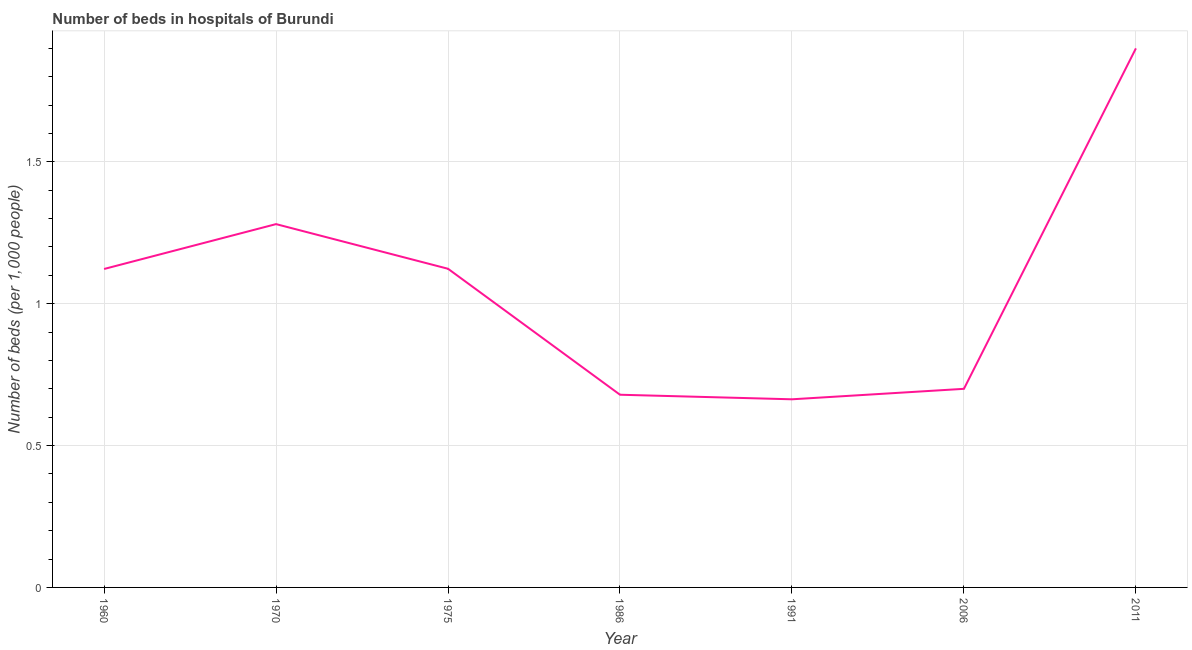Across all years, what is the minimum number of hospital beds?
Keep it short and to the point. 0.66. In which year was the number of hospital beds maximum?
Keep it short and to the point. 2011. What is the sum of the number of hospital beds?
Your answer should be compact. 7.47. What is the difference between the number of hospital beds in 1975 and 2006?
Your response must be concise. 0.42. What is the average number of hospital beds per year?
Keep it short and to the point. 1.07. What is the median number of hospital beds?
Ensure brevity in your answer.  1.12. In how many years, is the number of hospital beds greater than 0.5 %?
Provide a succinct answer. 7. What is the ratio of the number of hospital beds in 1970 to that in 2006?
Provide a succinct answer. 1.83. Is the number of hospital beds in 1991 less than that in 2011?
Your answer should be very brief. Yes. Is the difference between the number of hospital beds in 1960 and 1970 greater than the difference between any two years?
Your answer should be compact. No. What is the difference between the highest and the second highest number of hospital beds?
Give a very brief answer. 0.62. What is the difference between the highest and the lowest number of hospital beds?
Your answer should be compact. 1.24. In how many years, is the number of hospital beds greater than the average number of hospital beds taken over all years?
Offer a terse response. 4. How many lines are there?
Provide a short and direct response. 1. What is the difference between two consecutive major ticks on the Y-axis?
Give a very brief answer. 0.5. Does the graph contain any zero values?
Provide a succinct answer. No. Does the graph contain grids?
Give a very brief answer. Yes. What is the title of the graph?
Give a very brief answer. Number of beds in hospitals of Burundi. What is the label or title of the Y-axis?
Ensure brevity in your answer.  Number of beds (per 1,0 people). What is the Number of beds (per 1,000 people) of 1960?
Offer a very short reply. 1.12. What is the Number of beds (per 1,000 people) of 1970?
Your answer should be compact. 1.28. What is the Number of beds (per 1,000 people) in 1975?
Your answer should be very brief. 1.12. What is the Number of beds (per 1,000 people) in 1986?
Make the answer very short. 0.68. What is the Number of beds (per 1,000 people) in 1991?
Offer a very short reply. 0.66. What is the Number of beds (per 1,000 people) in 2011?
Your answer should be very brief. 1.9. What is the difference between the Number of beds (per 1,000 people) in 1960 and 1970?
Provide a succinct answer. -0.16. What is the difference between the Number of beds (per 1,000 people) in 1960 and 1975?
Give a very brief answer. -0. What is the difference between the Number of beds (per 1,000 people) in 1960 and 1986?
Give a very brief answer. 0.44. What is the difference between the Number of beds (per 1,000 people) in 1960 and 1991?
Ensure brevity in your answer.  0.46. What is the difference between the Number of beds (per 1,000 people) in 1960 and 2006?
Offer a very short reply. 0.42. What is the difference between the Number of beds (per 1,000 people) in 1960 and 2011?
Make the answer very short. -0.78. What is the difference between the Number of beds (per 1,000 people) in 1970 and 1975?
Provide a succinct answer. 0.16. What is the difference between the Number of beds (per 1,000 people) in 1970 and 1986?
Ensure brevity in your answer.  0.6. What is the difference between the Number of beds (per 1,000 people) in 1970 and 1991?
Offer a terse response. 0.62. What is the difference between the Number of beds (per 1,000 people) in 1970 and 2006?
Offer a very short reply. 0.58. What is the difference between the Number of beds (per 1,000 people) in 1970 and 2011?
Ensure brevity in your answer.  -0.62. What is the difference between the Number of beds (per 1,000 people) in 1975 and 1986?
Make the answer very short. 0.44. What is the difference between the Number of beds (per 1,000 people) in 1975 and 1991?
Give a very brief answer. 0.46. What is the difference between the Number of beds (per 1,000 people) in 1975 and 2006?
Your response must be concise. 0.42. What is the difference between the Number of beds (per 1,000 people) in 1975 and 2011?
Provide a succinct answer. -0.78. What is the difference between the Number of beds (per 1,000 people) in 1986 and 1991?
Make the answer very short. 0.02. What is the difference between the Number of beds (per 1,000 people) in 1986 and 2006?
Keep it short and to the point. -0.02. What is the difference between the Number of beds (per 1,000 people) in 1986 and 2011?
Give a very brief answer. -1.22. What is the difference between the Number of beds (per 1,000 people) in 1991 and 2006?
Offer a very short reply. -0.04. What is the difference between the Number of beds (per 1,000 people) in 1991 and 2011?
Make the answer very short. -1.24. What is the difference between the Number of beds (per 1,000 people) in 2006 and 2011?
Your answer should be compact. -1.2. What is the ratio of the Number of beds (per 1,000 people) in 1960 to that in 1970?
Your response must be concise. 0.88. What is the ratio of the Number of beds (per 1,000 people) in 1960 to that in 1986?
Offer a terse response. 1.65. What is the ratio of the Number of beds (per 1,000 people) in 1960 to that in 1991?
Provide a succinct answer. 1.69. What is the ratio of the Number of beds (per 1,000 people) in 1960 to that in 2006?
Provide a short and direct response. 1.6. What is the ratio of the Number of beds (per 1,000 people) in 1960 to that in 2011?
Your answer should be compact. 0.59. What is the ratio of the Number of beds (per 1,000 people) in 1970 to that in 1975?
Offer a very short reply. 1.14. What is the ratio of the Number of beds (per 1,000 people) in 1970 to that in 1986?
Give a very brief answer. 1.89. What is the ratio of the Number of beds (per 1,000 people) in 1970 to that in 1991?
Offer a very short reply. 1.93. What is the ratio of the Number of beds (per 1,000 people) in 1970 to that in 2006?
Give a very brief answer. 1.83. What is the ratio of the Number of beds (per 1,000 people) in 1970 to that in 2011?
Make the answer very short. 0.67. What is the ratio of the Number of beds (per 1,000 people) in 1975 to that in 1986?
Your response must be concise. 1.65. What is the ratio of the Number of beds (per 1,000 people) in 1975 to that in 1991?
Provide a succinct answer. 1.69. What is the ratio of the Number of beds (per 1,000 people) in 1975 to that in 2006?
Offer a very short reply. 1.6. What is the ratio of the Number of beds (per 1,000 people) in 1975 to that in 2011?
Offer a terse response. 0.59. What is the ratio of the Number of beds (per 1,000 people) in 1986 to that in 2006?
Give a very brief answer. 0.97. What is the ratio of the Number of beds (per 1,000 people) in 1986 to that in 2011?
Offer a terse response. 0.36. What is the ratio of the Number of beds (per 1,000 people) in 1991 to that in 2006?
Make the answer very short. 0.95. What is the ratio of the Number of beds (per 1,000 people) in 1991 to that in 2011?
Provide a short and direct response. 0.35. What is the ratio of the Number of beds (per 1,000 people) in 2006 to that in 2011?
Provide a short and direct response. 0.37. 